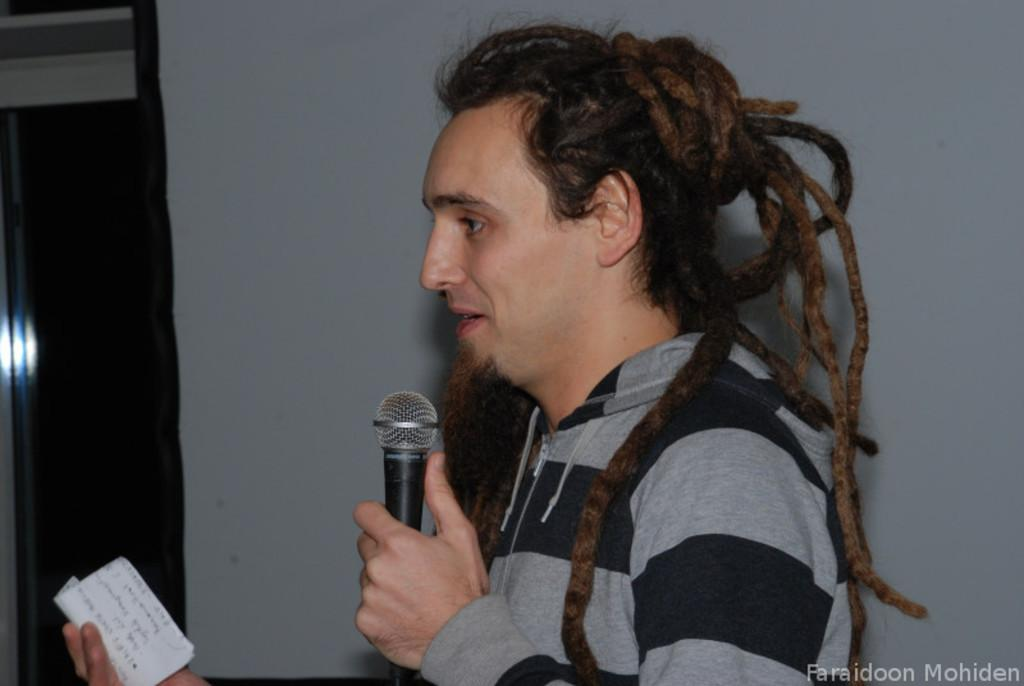Who or what is the main subject in the image? There is a person in the image. What is the person holding in their hands? The person is holding a mic and a paper. What can be seen in the background of the image? There is a wall in the background of the image. How many cracks are visible on the wall in the image? There is no mention of cracks on the wall in the image, so it is not possible to determine the number of cracks. 